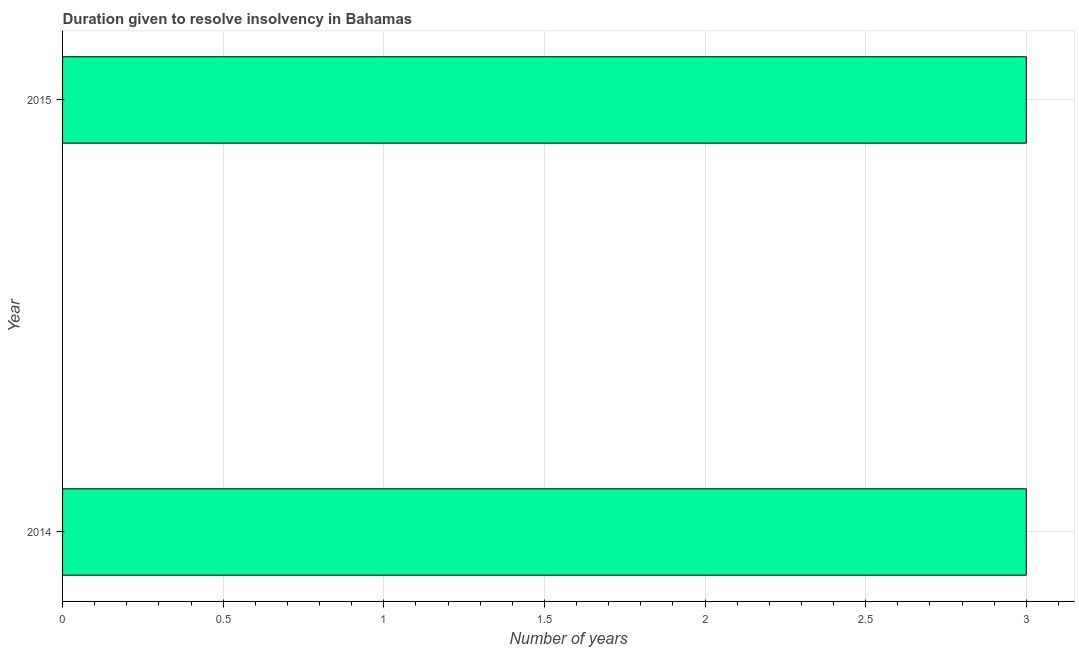Does the graph contain any zero values?
Provide a short and direct response. No. Does the graph contain grids?
Provide a short and direct response. Yes. What is the title of the graph?
Provide a short and direct response. Duration given to resolve insolvency in Bahamas. What is the label or title of the X-axis?
Offer a terse response. Number of years. What is the label or title of the Y-axis?
Ensure brevity in your answer.  Year. Across all years, what is the maximum number of years to resolve insolvency?
Your answer should be compact. 3. Across all years, what is the minimum number of years to resolve insolvency?
Ensure brevity in your answer.  3. In which year was the number of years to resolve insolvency minimum?
Keep it short and to the point. 2014. What is the sum of the number of years to resolve insolvency?
Make the answer very short. 6. In how many years, is the number of years to resolve insolvency greater than 0.9 ?
Your answer should be very brief. 2. What is the ratio of the number of years to resolve insolvency in 2014 to that in 2015?
Offer a very short reply. 1. In how many years, is the number of years to resolve insolvency greater than the average number of years to resolve insolvency taken over all years?
Give a very brief answer. 0. Are all the bars in the graph horizontal?
Offer a very short reply. Yes. How many years are there in the graph?
Provide a succinct answer. 2. What is the difference between two consecutive major ticks on the X-axis?
Your answer should be compact. 0.5. Are the values on the major ticks of X-axis written in scientific E-notation?
Ensure brevity in your answer.  No. What is the Number of years in 2014?
Your response must be concise. 3. What is the Number of years in 2015?
Offer a terse response. 3. What is the ratio of the Number of years in 2014 to that in 2015?
Make the answer very short. 1. 